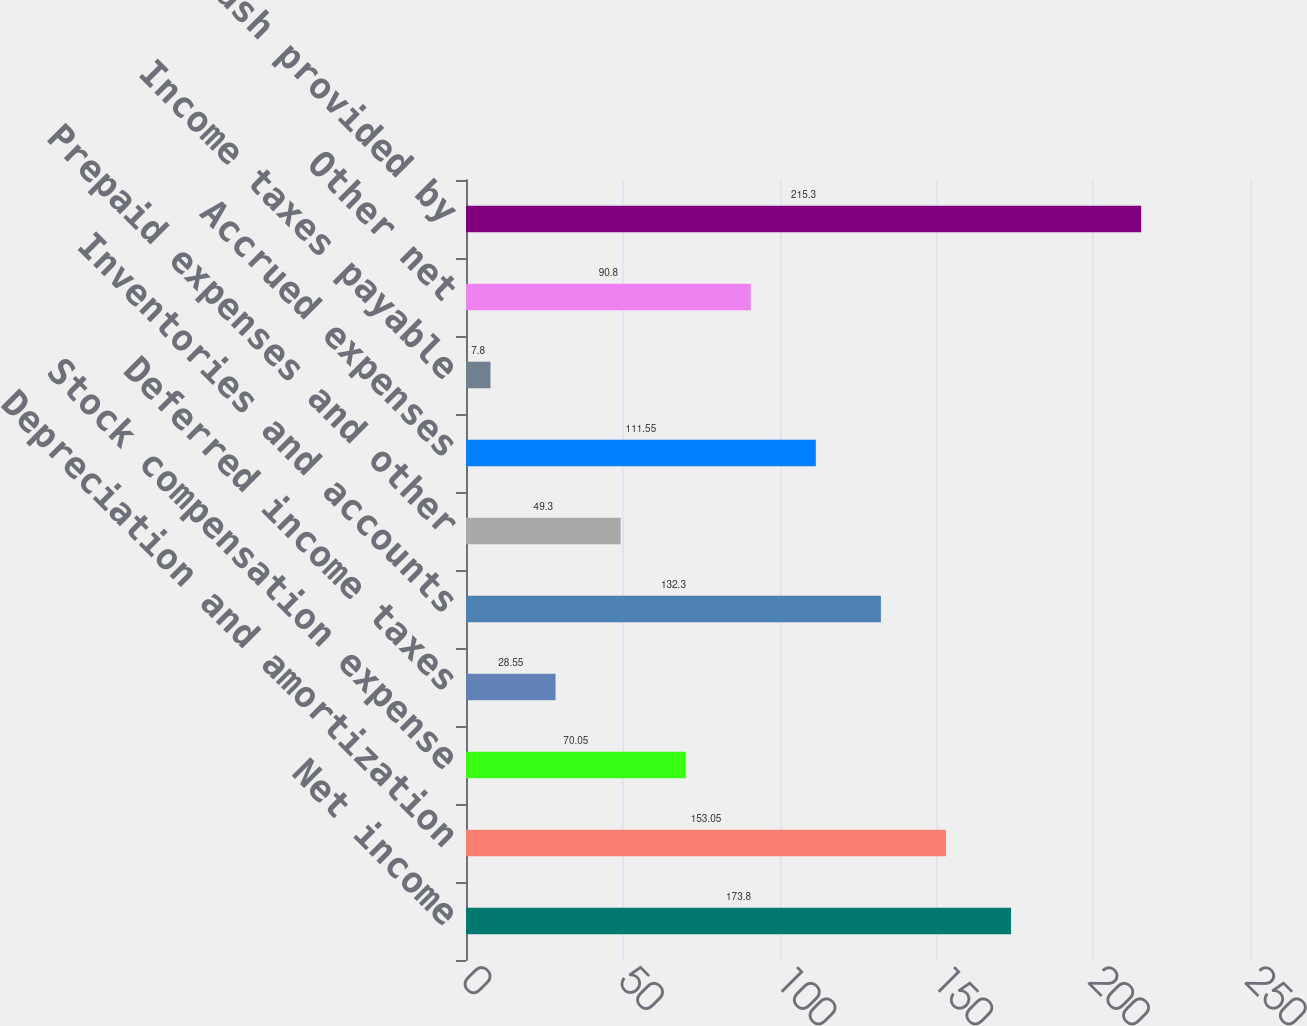Convert chart to OTSL. <chart><loc_0><loc_0><loc_500><loc_500><bar_chart><fcel>Net income<fcel>Depreciation and amortization<fcel>Stock compensation expense<fcel>Deferred income taxes<fcel>Inventories and accounts<fcel>Prepaid expenses and other<fcel>Accrued expenses<fcel>Income taxes payable<fcel>Other net<fcel>Net cash provided by<nl><fcel>173.8<fcel>153.05<fcel>70.05<fcel>28.55<fcel>132.3<fcel>49.3<fcel>111.55<fcel>7.8<fcel>90.8<fcel>215.3<nl></chart> 